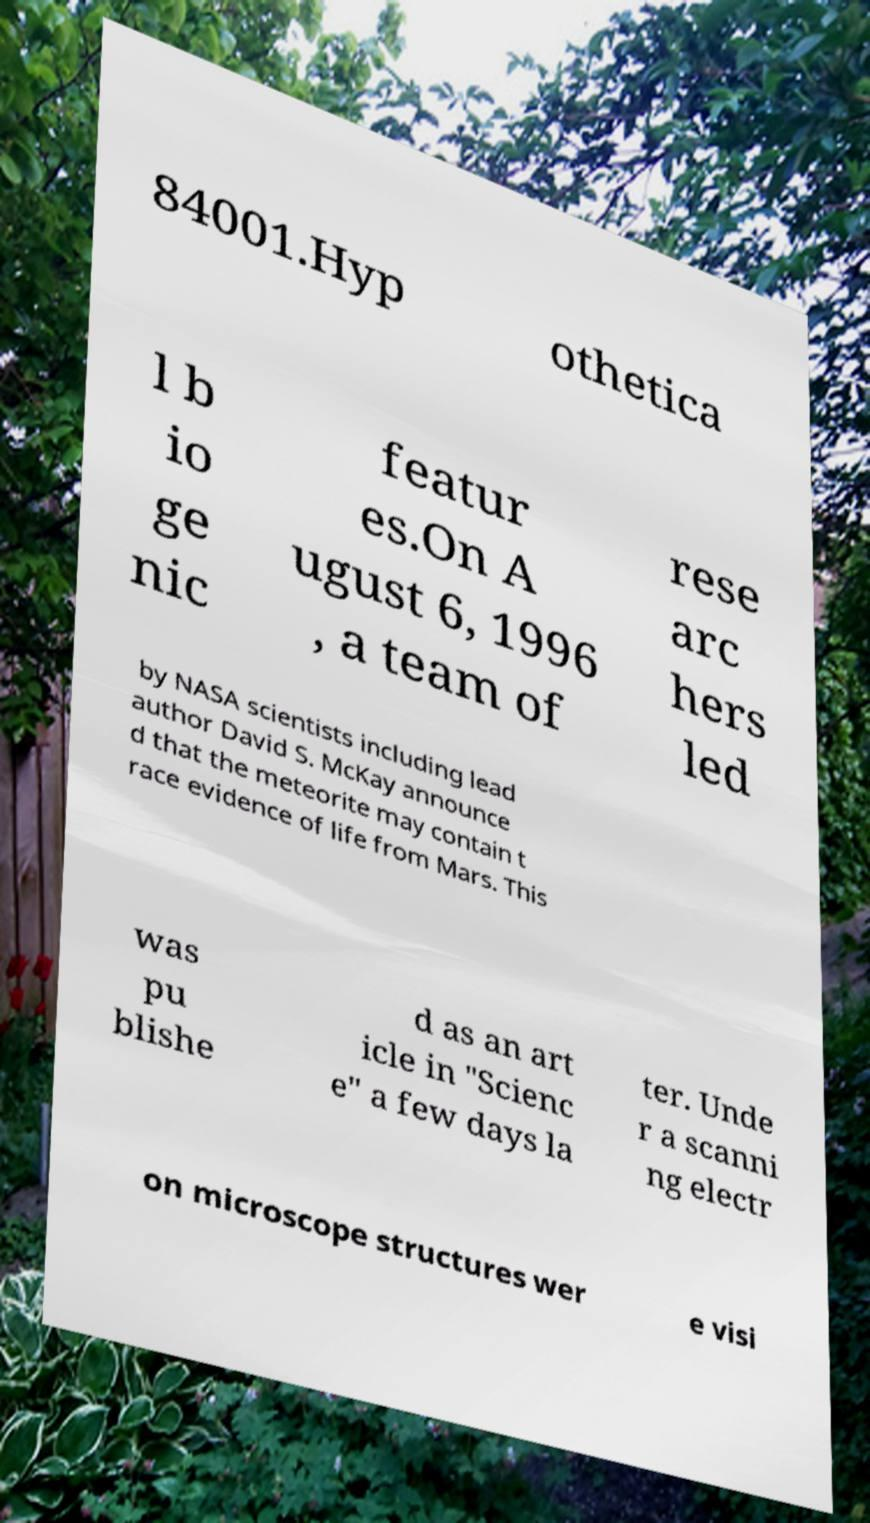For documentation purposes, I need the text within this image transcribed. Could you provide that? 84001.Hyp othetica l b io ge nic featur es.On A ugust 6, 1996 , a team of rese arc hers led by NASA scientists including lead author David S. McKay announce d that the meteorite may contain t race evidence of life from Mars. This was pu blishe d as an art icle in "Scienc e" a few days la ter. Unde r a scanni ng electr on microscope structures wer e visi 